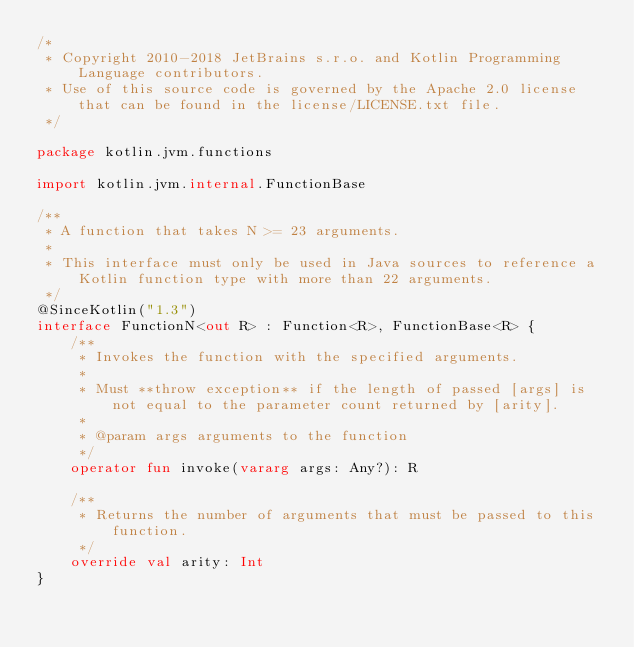Convert code to text. <code><loc_0><loc_0><loc_500><loc_500><_Kotlin_>/*
 * Copyright 2010-2018 JetBrains s.r.o. and Kotlin Programming Language contributors.
 * Use of this source code is governed by the Apache 2.0 license that can be found in the license/LICENSE.txt file.
 */

package kotlin.jvm.functions

import kotlin.jvm.internal.FunctionBase

/**
 * A function that takes N >= 23 arguments.
 *
 * This interface must only be used in Java sources to reference a Kotlin function type with more than 22 arguments.
 */
@SinceKotlin("1.3")
interface FunctionN<out R> : Function<R>, FunctionBase<R> {
    /**
     * Invokes the function with the specified arguments.
     *
     * Must **throw exception** if the length of passed [args] is not equal to the parameter count returned by [arity].
     *
     * @param args arguments to the function
     */
    operator fun invoke(vararg args: Any?): R

    /**
     * Returns the number of arguments that must be passed to this function.
     */
    override val arity: Int
}
</code> 